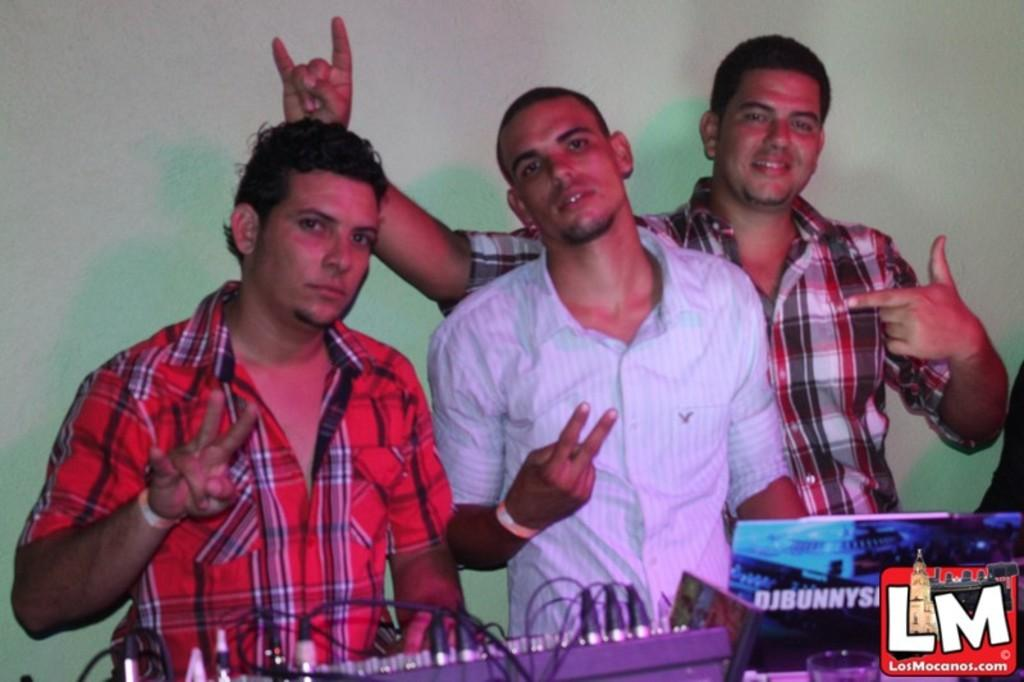How many men are in the image? There are three men standing in the image. What are the men wearing? The men are wearing clothes. What else can be seen in the image besides the men? There are cable wires, a watermark, a musical instrument, a wall, and a hand band visible in the image. What type of bean is being sold in the shop in the image? There is no shop present in the image, and therefore no beans being sold. How many thumbs can be seen on the men's hands in the image? The number of thumbs cannot be determined from the image, as only the men's clothes are visible. 